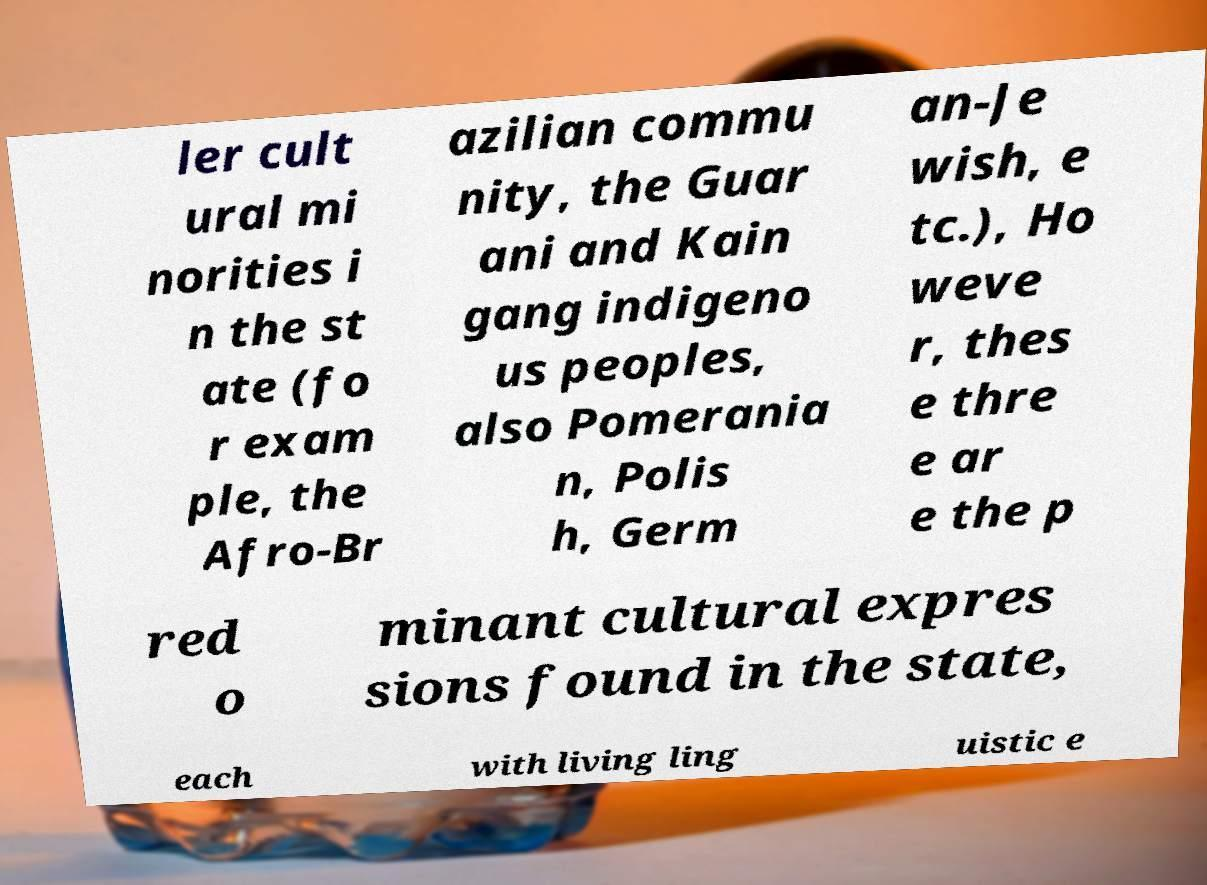Could you assist in decoding the text presented in this image and type it out clearly? ler cult ural mi norities i n the st ate (fo r exam ple, the Afro-Br azilian commu nity, the Guar ani and Kain gang indigeno us peoples, also Pomerania n, Polis h, Germ an-Je wish, e tc.), Ho weve r, thes e thre e ar e the p red o minant cultural expres sions found in the state, each with living ling uistic e 